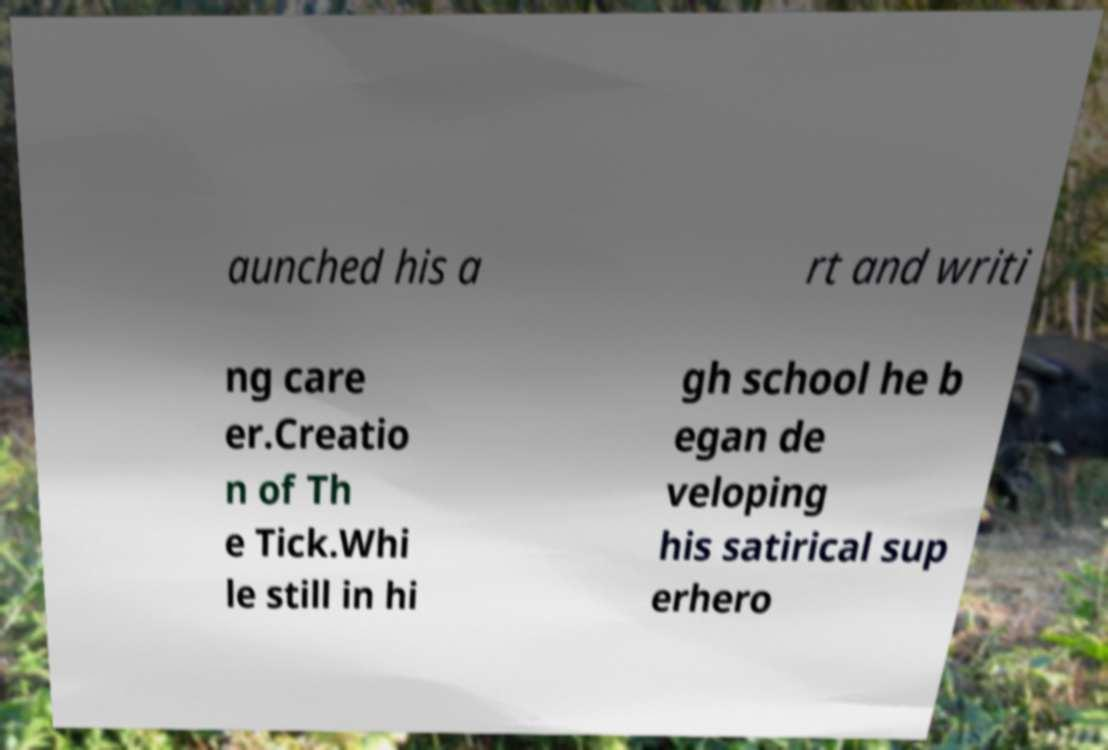Please identify and transcribe the text found in this image. aunched his a rt and writi ng care er.Creatio n of Th e Tick.Whi le still in hi gh school he b egan de veloping his satirical sup erhero 